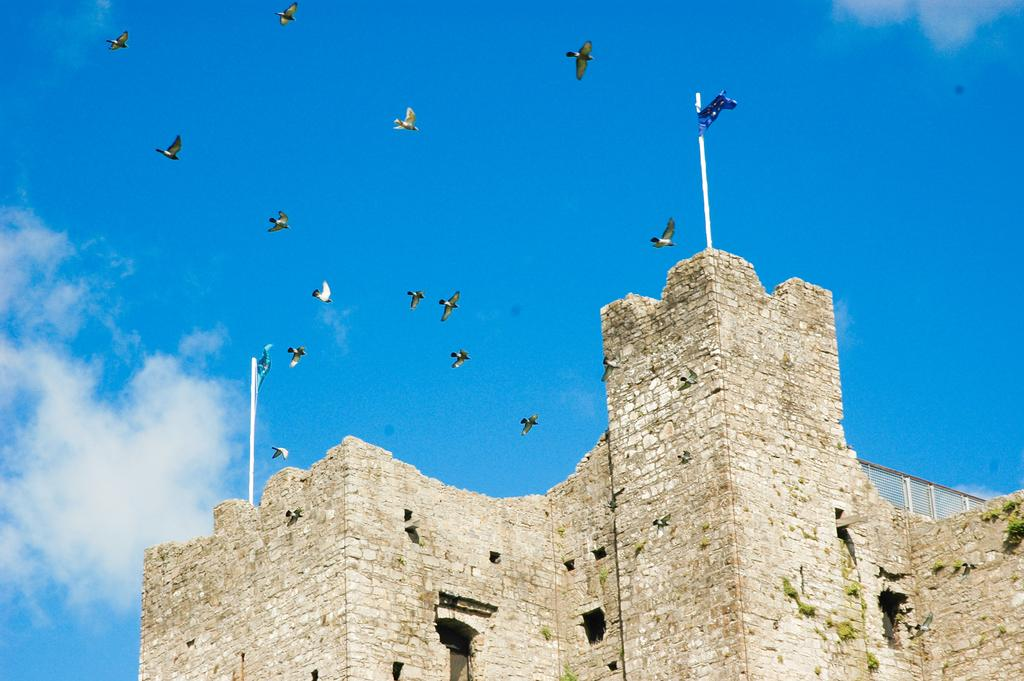What is happening in the sky in the image? There are birds flying in the air in the image. What type of structure can be seen in the image? There is a building visible in the image. Are there any flags near the building? Yes, there are two flags near the building. What can be seen in the background of the image? There are clouds and a blue sky in the background of the image. Can you tell me how many geese are flying near the building in the image? There are no geese present in the image; it features birds, but their specific type is not mentioned. What type of bomb is being dropped from the sky in the image? There is no bomb present in the image; it only shows birds flying in the sky. 